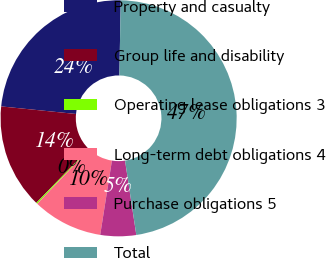<chart> <loc_0><loc_0><loc_500><loc_500><pie_chart><fcel>Property and casualty<fcel>Group life and disability<fcel>Operating lease obligations 3<fcel>Long-term debt obligations 4<fcel>Purchase obligations 5<fcel>Total<nl><fcel>23.68%<fcel>14.32%<fcel>0.18%<fcel>9.61%<fcel>4.89%<fcel>47.32%<nl></chart> 